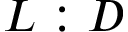<formula> <loc_0><loc_0><loc_500><loc_500>L \colon D</formula> 